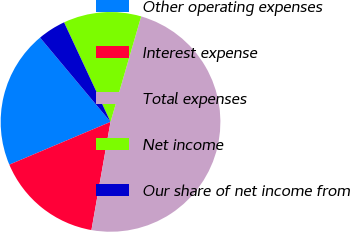<chart> <loc_0><loc_0><loc_500><loc_500><pie_chart><fcel>Other operating expenses<fcel>Interest expense<fcel>Total expenses<fcel>Net income<fcel>Our share of net income from<nl><fcel>20.28%<fcel>15.86%<fcel>48.28%<fcel>11.45%<fcel>4.13%<nl></chart> 